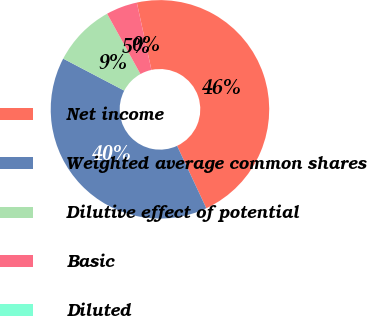Convert chart. <chart><loc_0><loc_0><loc_500><loc_500><pie_chart><fcel>Net income<fcel>Weighted average common shares<fcel>Dilutive effect of potential<fcel>Basic<fcel>Diluted<nl><fcel>46.42%<fcel>39.65%<fcel>9.28%<fcel>4.64%<fcel>0.0%<nl></chart> 